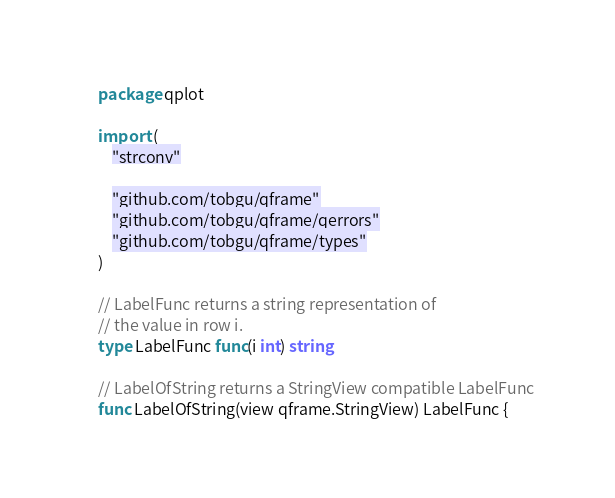<code> <loc_0><loc_0><loc_500><loc_500><_Go_>package qplot

import (
	"strconv"

	"github.com/tobgu/qframe"
	"github.com/tobgu/qframe/qerrors"
	"github.com/tobgu/qframe/types"
)

// LabelFunc returns a string representation of
// the value in row i.
type LabelFunc func(i int) string

// LabelOfString returns a StringView compatible LabelFunc
func LabelOfString(view qframe.StringView) LabelFunc {</code> 